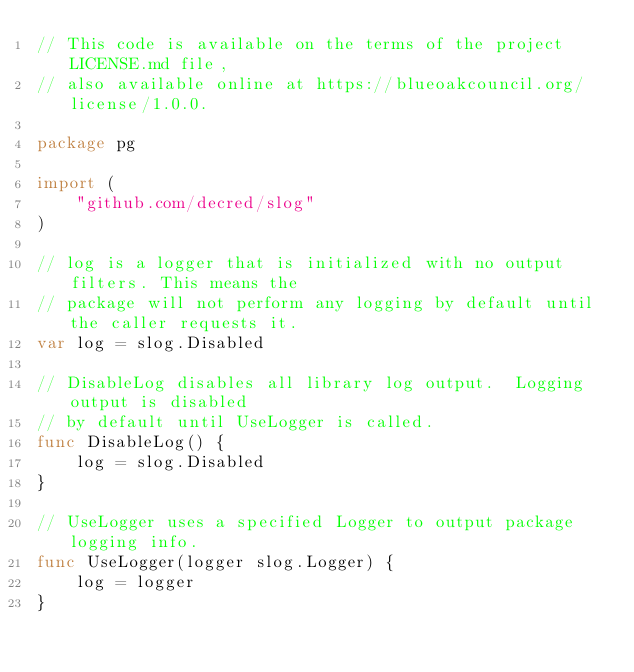<code> <loc_0><loc_0><loc_500><loc_500><_Go_>// This code is available on the terms of the project LICENSE.md file,
// also available online at https://blueoakcouncil.org/license/1.0.0.

package pg

import (
	"github.com/decred/slog"
)

// log is a logger that is initialized with no output filters. This means the
// package will not perform any logging by default until the caller requests it.
var log = slog.Disabled

// DisableLog disables all library log output.  Logging output is disabled
// by default until UseLogger is called.
func DisableLog() {
	log = slog.Disabled
}

// UseLogger uses a specified Logger to output package logging info.
func UseLogger(logger slog.Logger) {
	log = logger
}
</code> 